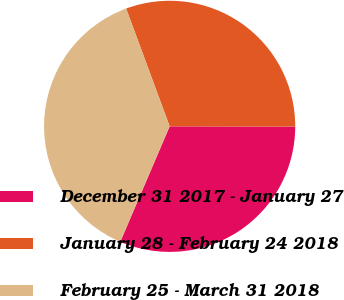Convert chart to OTSL. <chart><loc_0><loc_0><loc_500><loc_500><pie_chart><fcel>December 31 2017 - January 27<fcel>January 28 - February 24 2018<fcel>February 25 - March 31 2018<nl><fcel>31.4%<fcel>30.67%<fcel>37.93%<nl></chart> 